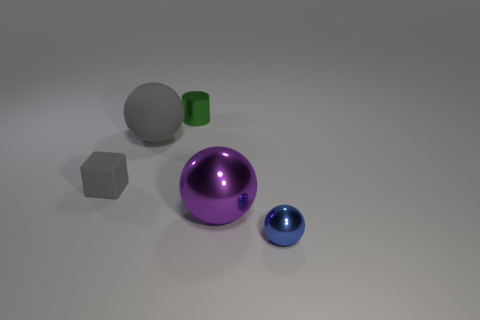Is there anything else that has the same shape as the small green object?
Give a very brief answer. No. There is a small thing that is the same color as the large matte sphere; what material is it?
Provide a short and direct response. Rubber. Is the number of large gray matte balls less than the number of metallic objects?
Offer a very short reply. Yes. Do the ball that is behind the small matte cube and the shiny thing that is behind the gray cube have the same size?
Provide a succinct answer. No. What number of objects are small green spheres or large purple shiny things?
Your answer should be very brief. 1. What size is the sphere left of the green metallic cylinder?
Keep it short and to the point. Large. What number of gray rubber blocks are on the right side of the large ball that is to the left of the small metallic object on the left side of the big metal ball?
Provide a succinct answer. 0. Is the small metallic cylinder the same color as the big rubber object?
Make the answer very short. No. What number of balls are both behind the tiny blue thing and to the right of the tiny green cylinder?
Your response must be concise. 1. There is a small metallic object behind the small sphere; what is its shape?
Provide a short and direct response. Cylinder. 